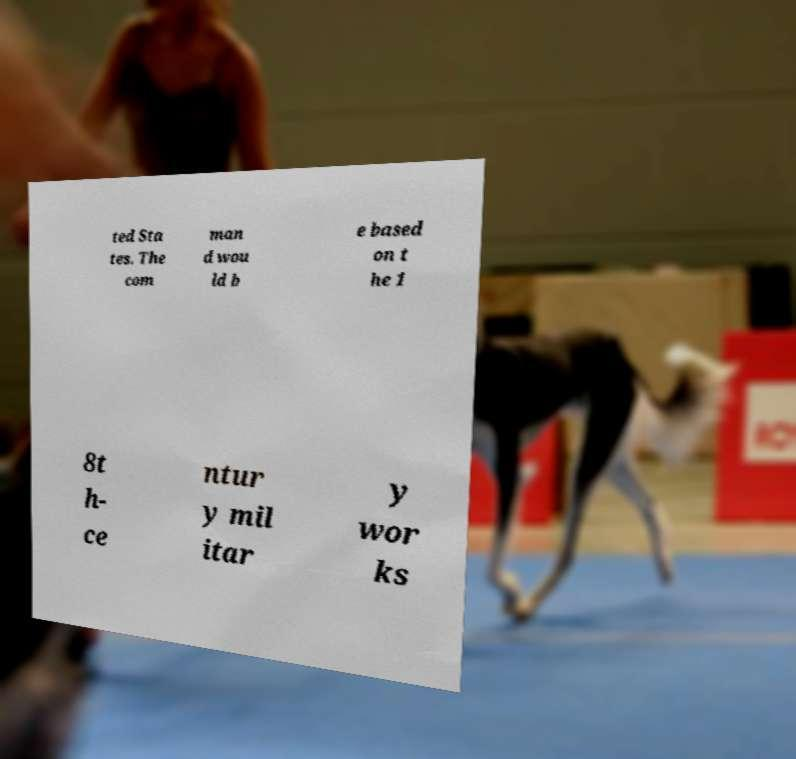Please identify and transcribe the text found in this image. ted Sta tes. The com man d wou ld b e based on t he 1 8t h- ce ntur y mil itar y wor ks 